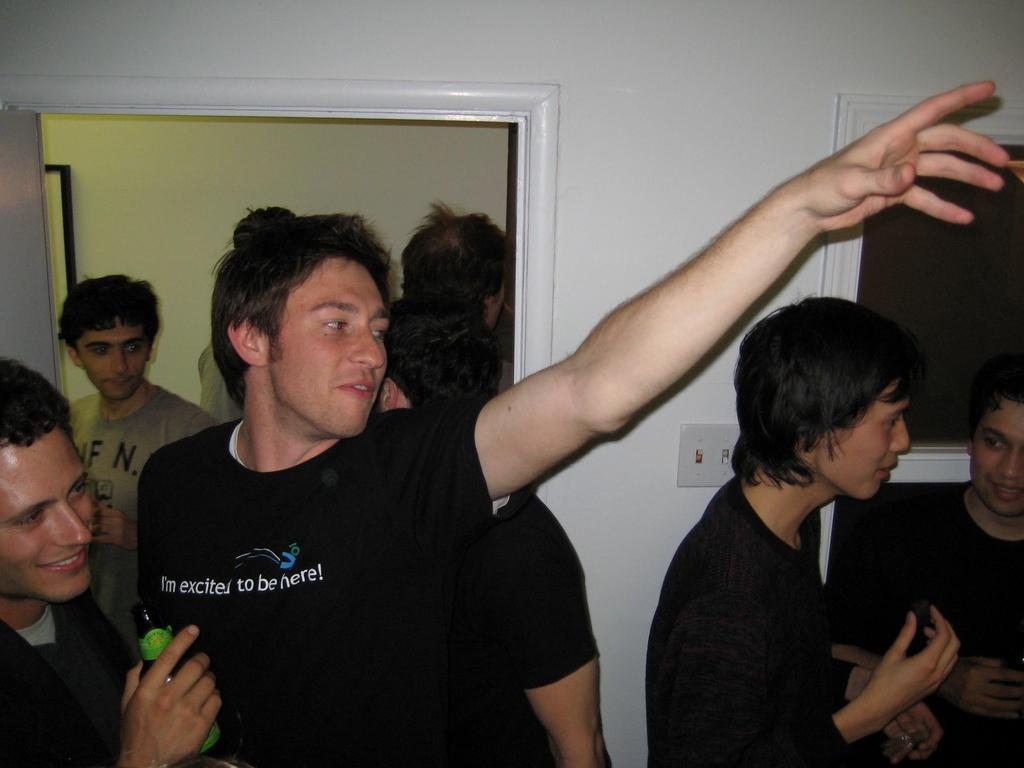How would you summarize this image in a sentence or two? In this picture I can see there is a man standing on to left and he is holding a beer bottle and there is a person standing next to him, he raised his hand and he is wearing a black shirt and there are two other people standing on right and they are talking. In the backdrop there is a white wall and a door. There are few people standing at the door. 